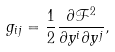<formula> <loc_0><loc_0><loc_500><loc_500>g _ { i j } = \frac { 1 } { 2 } \frac { \partial \mathcal { F } ^ { 2 } } { \partial y ^ { i } \partial y ^ { j } } ,</formula> 